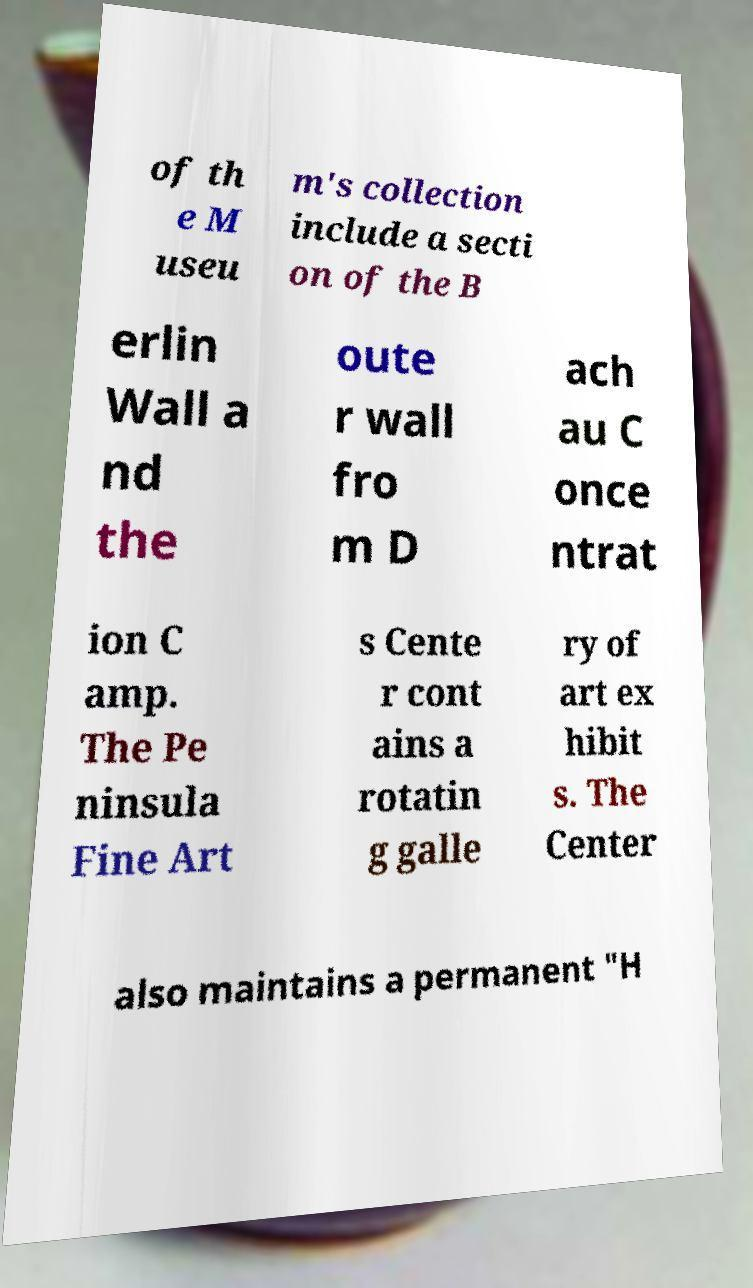What messages or text are displayed in this image? I need them in a readable, typed format. of th e M useu m's collection include a secti on of the B erlin Wall a nd the oute r wall fro m D ach au C once ntrat ion C amp. The Pe ninsula Fine Art s Cente r cont ains a rotatin g galle ry of art ex hibit s. The Center also maintains a permanent "H 